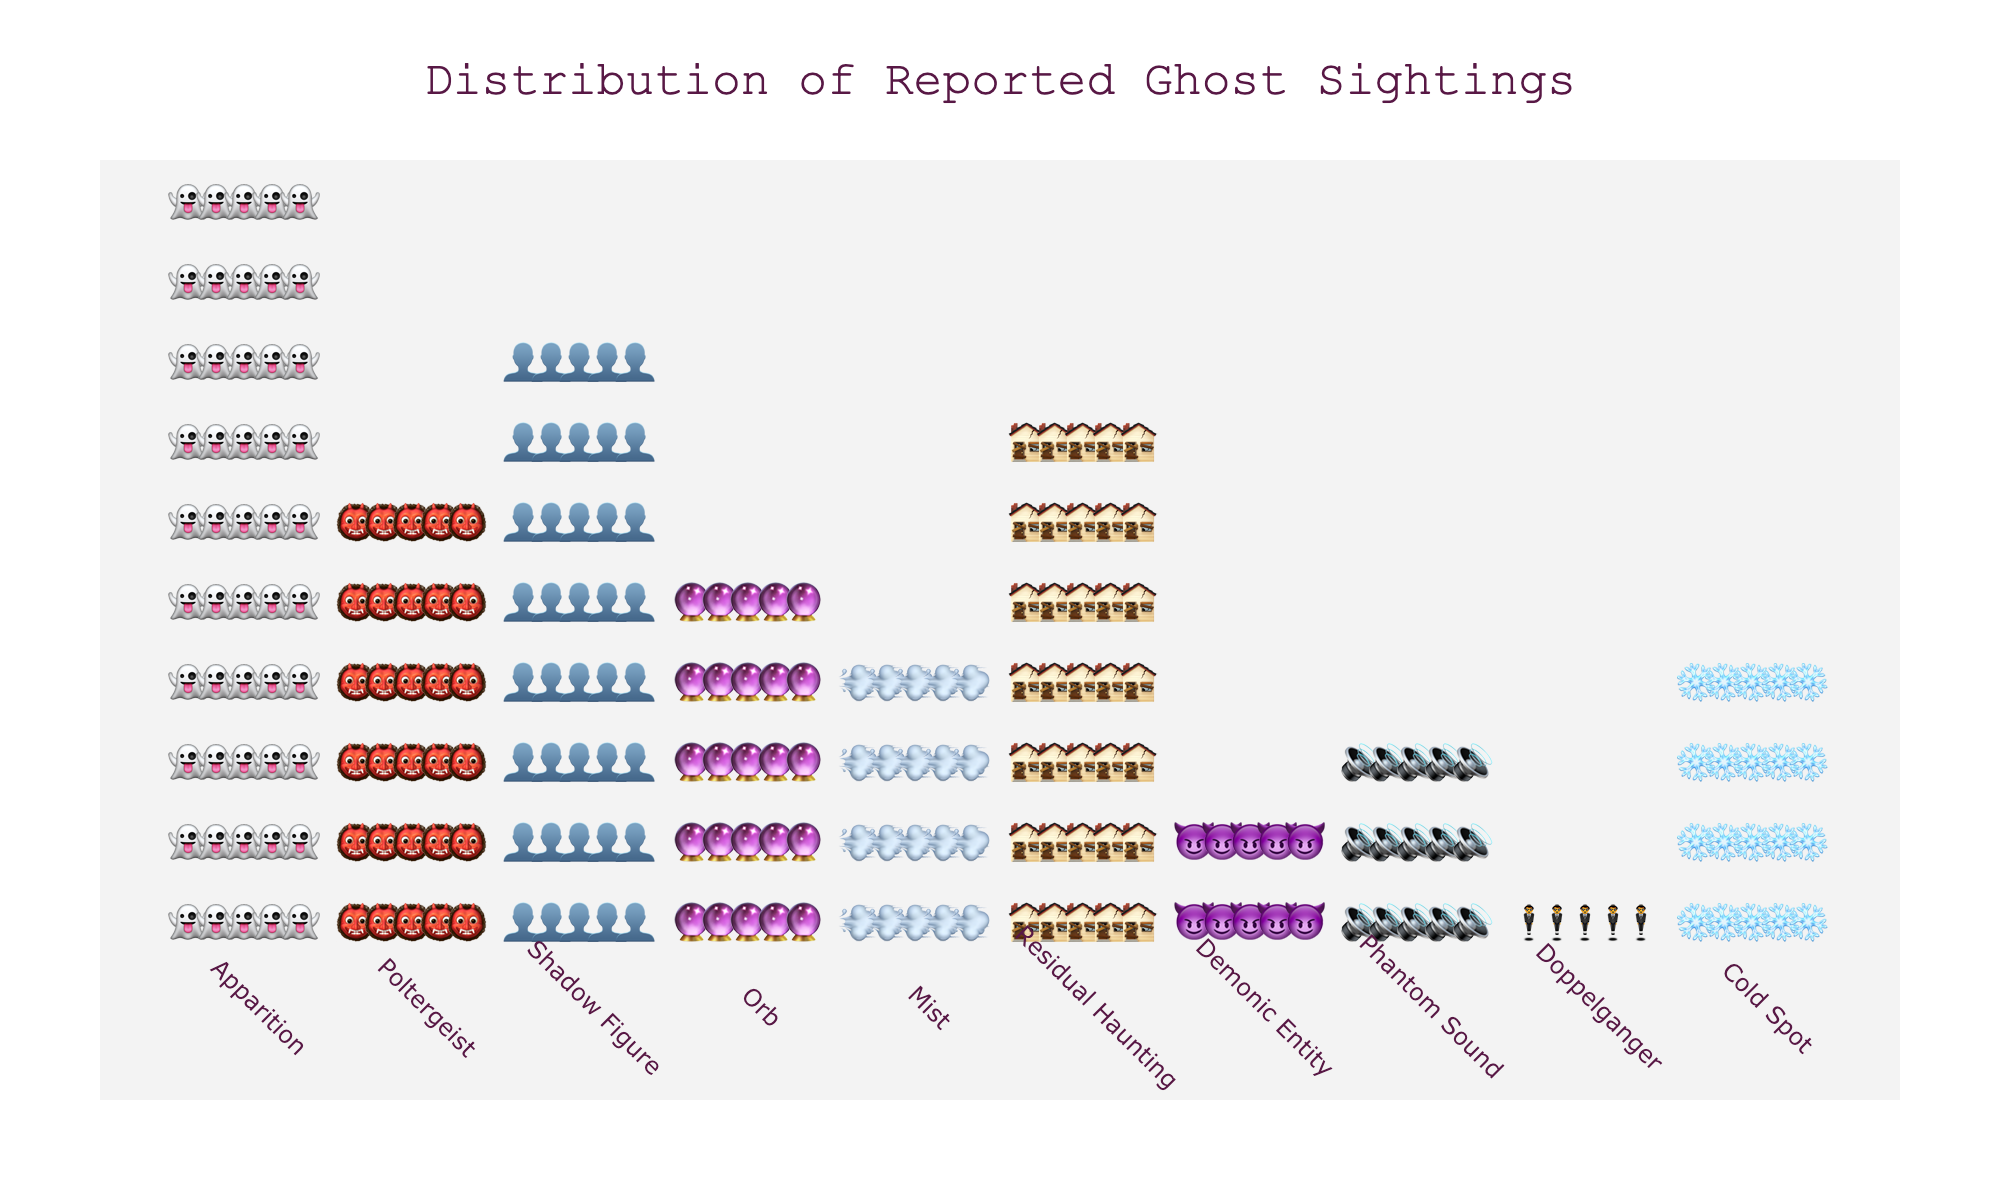How many Apparition sightings are reported in the figure? Count the number of ghost emojis representing Apparition, which is 50.
Answer: 50 Which ghost type has the least number of sightings? Identify the ghost type with the smallest number of emojis, which is Doppelganger with 5 sightings.
Answer: Doppelganger How many more Apparition sightings are there compared to Demonic Entity sightings? Subtract the number of Demonic Entity sightings (10) from Apparition sightings (50): 50 - 10 = 40.
Answer: 40 Which two ghost types have an equal number of sightings? Identify the ghost types with the same number of emojis. Cold Spot and Mist both have 20 sightings each.
Answer: Cold Spot and Mist What is the total number of ghost sightings reported in the figure? Sum the number of sightings for all ghost types: 50 + 30 + 40 + 25 + 20 + 35 + 10 + 15 + 5 + 20 = 250.
Answer: 250 How many more sightings are there of Poltergeists compared to Phantom Sounds? Subtract the number of Phantom Sound sightings (15) from Poltergeist sightings (30): 30 - 15 = 15.
Answer: 15 Which ghost type appears the second most frequently in the figure? Identify the ghost type with the second highest number of sightings. Shadow Figure has the second most sightings with 40.
Answer: Shadow Figure What is the ratio of Apparition sightings to Orb sightings? Divide the number of Apparition sightings (50) by Orb sightings (25): 50 / 25 = 2.
Answer: 2 How many ghost types have more than 30 sightings each? Count the number of ghost types with more than 30 sightings: Apparition (50), Poltergeist (30), Shadow Figure (40), Residual Haunting (35), totaling 4.
Answer: 4 By how much do sightings of Apparitions exceed the sightings of Residual Hauntings? Subtract Residual Haunting sightings (35) from Apparition sightings (50): 50 - 35 = 15.
Answer: 15 